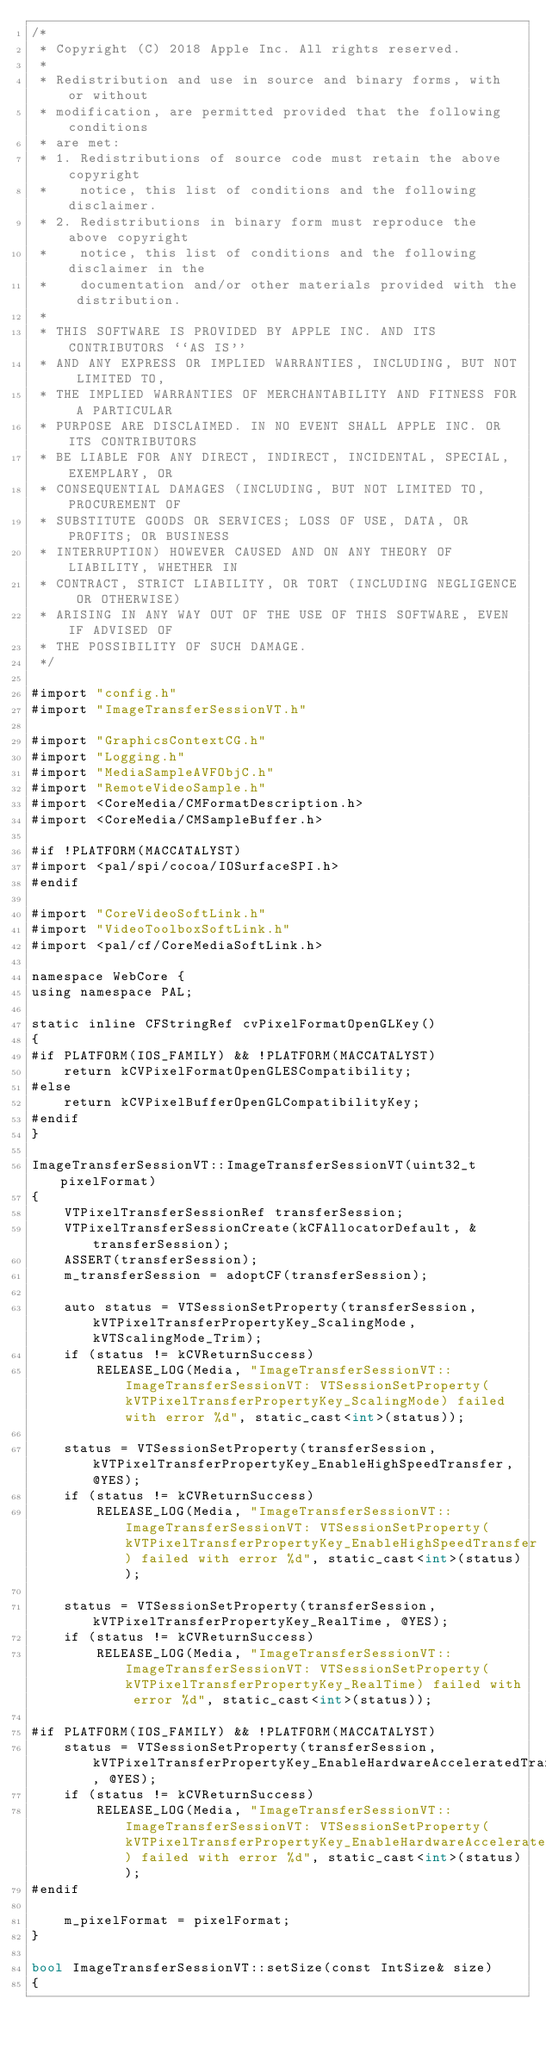<code> <loc_0><loc_0><loc_500><loc_500><_ObjectiveC_>/*
 * Copyright (C) 2018 Apple Inc. All rights reserved.
 * 
 * Redistribution and use in source and binary forms, with or without
 * modification, are permitted provided that the following conditions
 * are met:
 * 1. Redistributions of source code must retain the above copyright
 *    notice, this list of conditions and the following disclaimer.
 * 2. Redistributions in binary form must reproduce the above copyright
 *    notice, this list of conditions and the following disclaimer in the
 *    documentation and/or other materials provided with the distribution.
 *
 * THIS SOFTWARE IS PROVIDED BY APPLE INC. AND ITS CONTRIBUTORS ``AS IS''
 * AND ANY EXPRESS OR IMPLIED WARRANTIES, INCLUDING, BUT NOT LIMITED TO,
 * THE IMPLIED WARRANTIES OF MERCHANTABILITY AND FITNESS FOR A PARTICULAR
 * PURPOSE ARE DISCLAIMED. IN NO EVENT SHALL APPLE INC. OR ITS CONTRIBUTORS
 * BE LIABLE FOR ANY DIRECT, INDIRECT, INCIDENTAL, SPECIAL, EXEMPLARY, OR
 * CONSEQUENTIAL DAMAGES (INCLUDING, BUT NOT LIMITED TO, PROCUREMENT OF
 * SUBSTITUTE GOODS OR SERVICES; LOSS OF USE, DATA, OR PROFITS; OR BUSINESS
 * INTERRUPTION) HOWEVER CAUSED AND ON ANY THEORY OF LIABILITY, WHETHER IN
 * CONTRACT, STRICT LIABILITY, OR TORT (INCLUDING NEGLIGENCE OR OTHERWISE)
 * ARISING IN ANY WAY OUT OF THE USE OF THIS SOFTWARE, EVEN IF ADVISED OF
 * THE POSSIBILITY OF SUCH DAMAGE.
 */

#import "config.h"
#import "ImageTransferSessionVT.h"

#import "GraphicsContextCG.h"
#import "Logging.h"
#import "MediaSampleAVFObjC.h"
#import "RemoteVideoSample.h"
#import <CoreMedia/CMFormatDescription.h>
#import <CoreMedia/CMSampleBuffer.h>

#if !PLATFORM(MACCATALYST)
#import <pal/spi/cocoa/IOSurfaceSPI.h>
#endif

#import "CoreVideoSoftLink.h"
#import "VideoToolboxSoftLink.h"
#import <pal/cf/CoreMediaSoftLink.h>

namespace WebCore {
using namespace PAL;

static inline CFStringRef cvPixelFormatOpenGLKey()
{
#if PLATFORM(IOS_FAMILY) && !PLATFORM(MACCATALYST)
    return kCVPixelFormatOpenGLESCompatibility;
#else
    return kCVPixelBufferOpenGLCompatibilityKey;
#endif
}

ImageTransferSessionVT::ImageTransferSessionVT(uint32_t pixelFormat)
{
    VTPixelTransferSessionRef transferSession;
    VTPixelTransferSessionCreate(kCFAllocatorDefault, &transferSession);
    ASSERT(transferSession);
    m_transferSession = adoptCF(transferSession);

    auto status = VTSessionSetProperty(transferSession, kVTPixelTransferPropertyKey_ScalingMode, kVTScalingMode_Trim);
    if (status != kCVReturnSuccess)
        RELEASE_LOG(Media, "ImageTransferSessionVT::ImageTransferSessionVT: VTSessionSetProperty(kVTPixelTransferPropertyKey_ScalingMode) failed with error %d", static_cast<int>(status));

    status = VTSessionSetProperty(transferSession, kVTPixelTransferPropertyKey_EnableHighSpeedTransfer, @YES);
    if (status != kCVReturnSuccess)
        RELEASE_LOG(Media, "ImageTransferSessionVT::ImageTransferSessionVT: VTSessionSetProperty(kVTPixelTransferPropertyKey_EnableHighSpeedTransfer) failed with error %d", static_cast<int>(status));

    status = VTSessionSetProperty(transferSession, kVTPixelTransferPropertyKey_RealTime, @YES);
    if (status != kCVReturnSuccess)
        RELEASE_LOG(Media, "ImageTransferSessionVT::ImageTransferSessionVT: VTSessionSetProperty(kVTPixelTransferPropertyKey_RealTime) failed with error %d", static_cast<int>(status));

#if PLATFORM(IOS_FAMILY) && !PLATFORM(MACCATALYST)
    status = VTSessionSetProperty(transferSession, kVTPixelTransferPropertyKey_EnableHardwareAcceleratedTransfer, @YES);
    if (status != kCVReturnSuccess)
        RELEASE_LOG(Media, "ImageTransferSessionVT::ImageTransferSessionVT: VTSessionSetProperty(kVTPixelTransferPropertyKey_EnableHardwareAcceleratedTransfer) failed with error %d", static_cast<int>(status));
#endif

    m_pixelFormat = pixelFormat;
}

bool ImageTransferSessionVT::setSize(const IntSize& size)
{</code> 